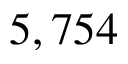Convert formula to latex. <formula><loc_0><loc_0><loc_500><loc_500>5 , 7 5 4</formula> 